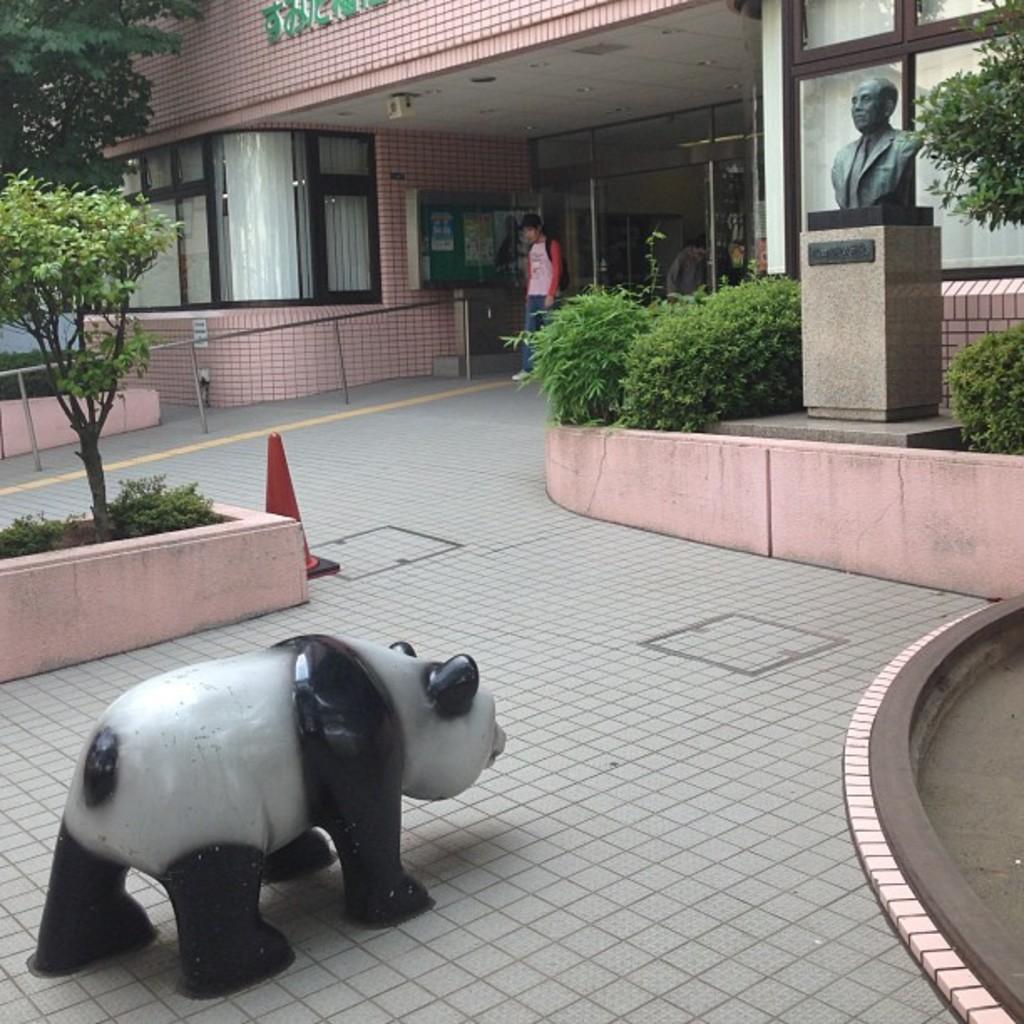How would you summarize this image in a sentence or two? In this picture I can observe a person walking on the land. There is a statue of a panda on the left side. I can observe a traffic cone. In the background there are trees and plants. On the right side I can observe a statue. There is a house in the background. 